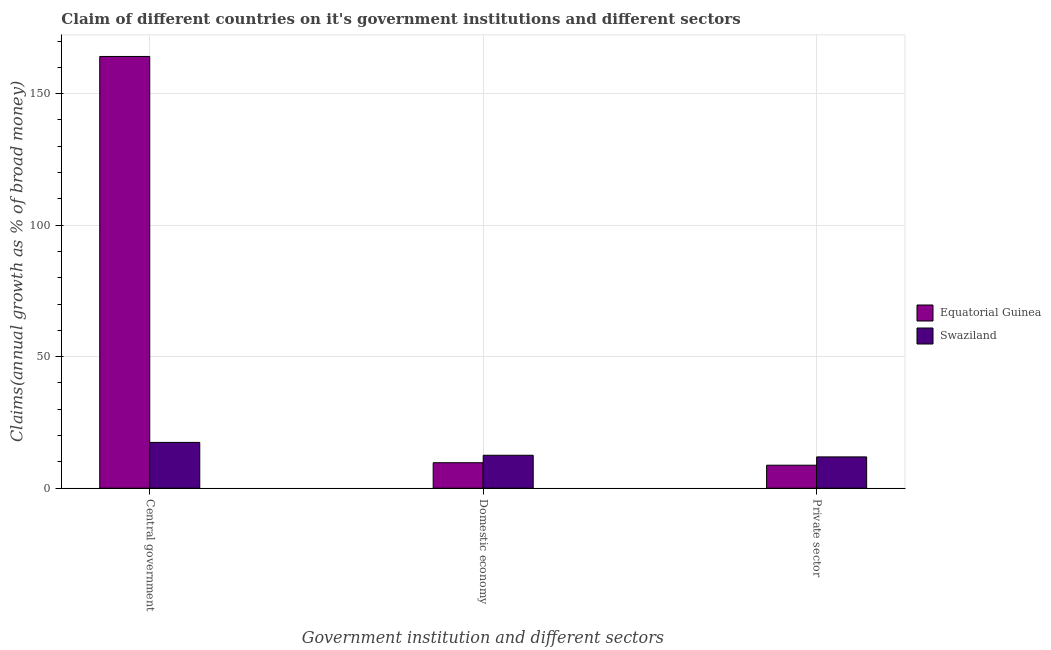How many groups of bars are there?
Your answer should be compact. 3. Are the number of bars per tick equal to the number of legend labels?
Provide a succinct answer. Yes. What is the label of the 3rd group of bars from the left?
Give a very brief answer. Private sector. What is the percentage of claim on the central government in Equatorial Guinea?
Your answer should be compact. 164.13. Across all countries, what is the maximum percentage of claim on the domestic economy?
Provide a succinct answer. 12.51. Across all countries, what is the minimum percentage of claim on the central government?
Provide a succinct answer. 17.4. In which country was the percentage of claim on the private sector maximum?
Give a very brief answer. Swaziland. In which country was the percentage of claim on the private sector minimum?
Keep it short and to the point. Equatorial Guinea. What is the total percentage of claim on the domestic economy in the graph?
Your response must be concise. 22.18. What is the difference between the percentage of claim on the private sector in Equatorial Guinea and that in Swaziland?
Give a very brief answer. -3.16. What is the difference between the percentage of claim on the private sector in Equatorial Guinea and the percentage of claim on the domestic economy in Swaziland?
Offer a very short reply. -3.79. What is the average percentage of claim on the private sector per country?
Provide a succinct answer. 10.31. What is the difference between the percentage of claim on the private sector and percentage of claim on the domestic economy in Equatorial Guinea?
Your response must be concise. -0.95. In how many countries, is the percentage of claim on the central government greater than 40 %?
Make the answer very short. 1. What is the ratio of the percentage of claim on the private sector in Equatorial Guinea to that in Swaziland?
Ensure brevity in your answer.  0.73. Is the percentage of claim on the private sector in Swaziland less than that in Equatorial Guinea?
Offer a very short reply. No. What is the difference between the highest and the second highest percentage of claim on the central government?
Offer a very short reply. 146.73. What is the difference between the highest and the lowest percentage of claim on the domestic economy?
Your answer should be compact. 2.84. Is the sum of the percentage of claim on the private sector in Swaziland and Equatorial Guinea greater than the maximum percentage of claim on the domestic economy across all countries?
Provide a short and direct response. Yes. What does the 1st bar from the left in Private sector represents?
Your answer should be very brief. Equatorial Guinea. What does the 1st bar from the right in Private sector represents?
Provide a succinct answer. Swaziland. Is it the case that in every country, the sum of the percentage of claim on the central government and percentage of claim on the domestic economy is greater than the percentage of claim on the private sector?
Keep it short and to the point. Yes. Are all the bars in the graph horizontal?
Provide a short and direct response. No. How many countries are there in the graph?
Make the answer very short. 2. What is the difference between two consecutive major ticks on the Y-axis?
Provide a short and direct response. 50. Does the graph contain any zero values?
Your answer should be very brief. No. Does the graph contain grids?
Give a very brief answer. Yes. How many legend labels are there?
Your answer should be very brief. 2. How are the legend labels stacked?
Give a very brief answer. Vertical. What is the title of the graph?
Offer a terse response. Claim of different countries on it's government institutions and different sectors. Does "Timor-Leste" appear as one of the legend labels in the graph?
Keep it short and to the point. No. What is the label or title of the X-axis?
Provide a short and direct response. Government institution and different sectors. What is the label or title of the Y-axis?
Give a very brief answer. Claims(annual growth as % of broad money). What is the Claims(annual growth as % of broad money) of Equatorial Guinea in Central government?
Your response must be concise. 164.13. What is the Claims(annual growth as % of broad money) in Swaziland in Central government?
Give a very brief answer. 17.4. What is the Claims(annual growth as % of broad money) of Equatorial Guinea in Domestic economy?
Make the answer very short. 9.67. What is the Claims(annual growth as % of broad money) of Swaziland in Domestic economy?
Provide a short and direct response. 12.51. What is the Claims(annual growth as % of broad money) in Equatorial Guinea in Private sector?
Ensure brevity in your answer.  8.73. What is the Claims(annual growth as % of broad money) in Swaziland in Private sector?
Make the answer very short. 11.89. Across all Government institution and different sectors, what is the maximum Claims(annual growth as % of broad money) in Equatorial Guinea?
Keep it short and to the point. 164.13. Across all Government institution and different sectors, what is the maximum Claims(annual growth as % of broad money) in Swaziland?
Offer a terse response. 17.4. Across all Government institution and different sectors, what is the minimum Claims(annual growth as % of broad money) in Equatorial Guinea?
Ensure brevity in your answer.  8.73. Across all Government institution and different sectors, what is the minimum Claims(annual growth as % of broad money) in Swaziland?
Make the answer very short. 11.89. What is the total Claims(annual growth as % of broad money) in Equatorial Guinea in the graph?
Offer a very short reply. 182.53. What is the total Claims(annual growth as % of broad money) of Swaziland in the graph?
Keep it short and to the point. 41.8. What is the difference between the Claims(annual growth as % of broad money) of Equatorial Guinea in Central government and that in Domestic economy?
Keep it short and to the point. 154.45. What is the difference between the Claims(annual growth as % of broad money) in Swaziland in Central government and that in Domestic economy?
Offer a very short reply. 4.89. What is the difference between the Claims(annual growth as % of broad money) in Equatorial Guinea in Central government and that in Private sector?
Your answer should be compact. 155.4. What is the difference between the Claims(annual growth as % of broad money) of Swaziland in Central government and that in Private sector?
Your answer should be compact. 5.51. What is the difference between the Claims(annual growth as % of broad money) in Equatorial Guinea in Domestic economy and that in Private sector?
Your answer should be very brief. 0.95. What is the difference between the Claims(annual growth as % of broad money) of Swaziland in Domestic economy and that in Private sector?
Ensure brevity in your answer.  0.63. What is the difference between the Claims(annual growth as % of broad money) of Equatorial Guinea in Central government and the Claims(annual growth as % of broad money) of Swaziland in Domestic economy?
Your answer should be very brief. 151.62. What is the difference between the Claims(annual growth as % of broad money) in Equatorial Guinea in Central government and the Claims(annual growth as % of broad money) in Swaziland in Private sector?
Provide a short and direct response. 152.24. What is the difference between the Claims(annual growth as % of broad money) in Equatorial Guinea in Domestic economy and the Claims(annual growth as % of broad money) in Swaziland in Private sector?
Ensure brevity in your answer.  -2.21. What is the average Claims(annual growth as % of broad money) of Equatorial Guinea per Government institution and different sectors?
Your response must be concise. 60.84. What is the average Claims(annual growth as % of broad money) of Swaziland per Government institution and different sectors?
Your answer should be compact. 13.93. What is the difference between the Claims(annual growth as % of broad money) of Equatorial Guinea and Claims(annual growth as % of broad money) of Swaziland in Central government?
Your answer should be compact. 146.73. What is the difference between the Claims(annual growth as % of broad money) of Equatorial Guinea and Claims(annual growth as % of broad money) of Swaziland in Domestic economy?
Offer a terse response. -2.84. What is the difference between the Claims(annual growth as % of broad money) of Equatorial Guinea and Claims(annual growth as % of broad money) of Swaziland in Private sector?
Ensure brevity in your answer.  -3.16. What is the ratio of the Claims(annual growth as % of broad money) in Equatorial Guinea in Central government to that in Domestic economy?
Offer a very short reply. 16.97. What is the ratio of the Claims(annual growth as % of broad money) of Swaziland in Central government to that in Domestic economy?
Make the answer very short. 1.39. What is the ratio of the Claims(annual growth as % of broad money) in Equatorial Guinea in Central government to that in Private sector?
Your answer should be very brief. 18.81. What is the ratio of the Claims(annual growth as % of broad money) of Swaziland in Central government to that in Private sector?
Keep it short and to the point. 1.46. What is the ratio of the Claims(annual growth as % of broad money) of Equatorial Guinea in Domestic economy to that in Private sector?
Provide a short and direct response. 1.11. What is the ratio of the Claims(annual growth as % of broad money) in Swaziland in Domestic economy to that in Private sector?
Provide a succinct answer. 1.05. What is the difference between the highest and the second highest Claims(annual growth as % of broad money) of Equatorial Guinea?
Your response must be concise. 154.45. What is the difference between the highest and the second highest Claims(annual growth as % of broad money) in Swaziland?
Provide a short and direct response. 4.89. What is the difference between the highest and the lowest Claims(annual growth as % of broad money) of Equatorial Guinea?
Your answer should be compact. 155.4. What is the difference between the highest and the lowest Claims(annual growth as % of broad money) of Swaziland?
Your answer should be compact. 5.51. 